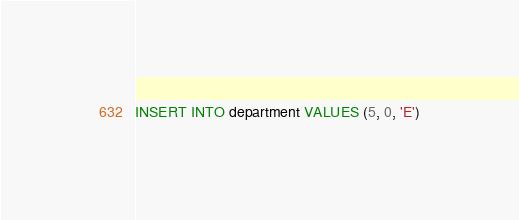Convert code to text. <code><loc_0><loc_0><loc_500><loc_500><_SQL_>INSERT INTO department VALUES (5, 0, 'E')
</code> 